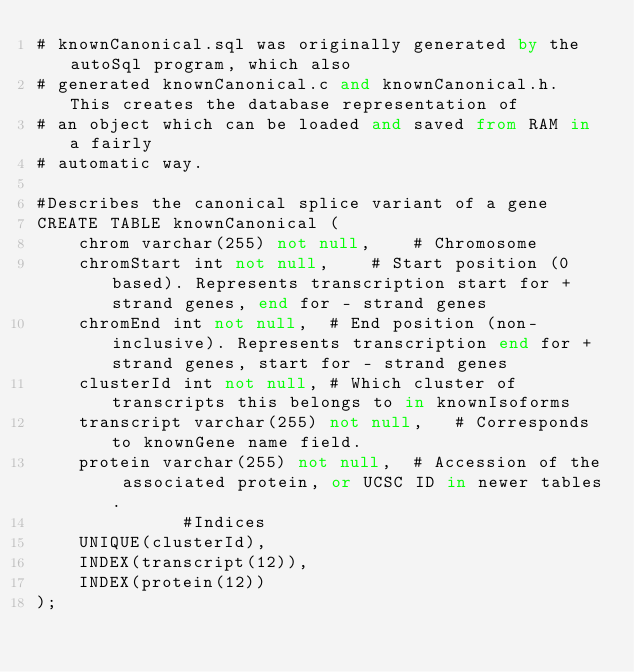<code> <loc_0><loc_0><loc_500><loc_500><_SQL_># knownCanonical.sql was originally generated by the autoSql program, which also 
# generated knownCanonical.c and knownCanonical.h.  This creates the database representation of
# an object which can be loaded and saved from RAM in a fairly 
# automatic way.

#Describes the canonical splice variant of a gene
CREATE TABLE knownCanonical (
    chrom varchar(255) not null,	# Chromosome
    chromStart int not null,	# Start position (0 based). Represents transcription start for + strand genes, end for - strand genes
    chromEnd int not null,	# End position (non-inclusive). Represents transcription end for + strand genes, start for - strand genes
    clusterId int not null,	# Which cluster of transcripts this belongs to in knownIsoforms
    transcript varchar(255) not null,	# Corresponds to knownGene name field.
    protein varchar(255) not null,	# Accession of the associated protein, or UCSC ID in newer tables.
              #Indices
    UNIQUE(clusterId),
    INDEX(transcript(12)),
    INDEX(protein(12))
);
</code> 